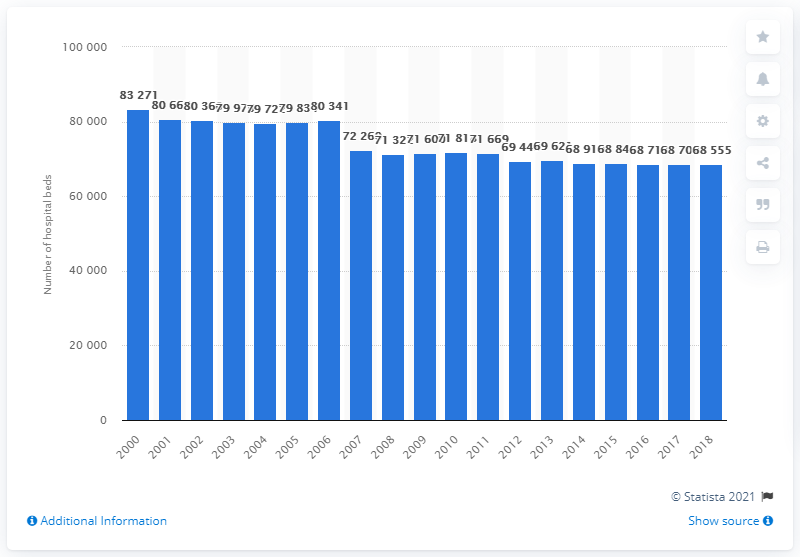Highlight a few significant elements in this photo. In 2000, the number of hospital beds in Hungary reached its peak. In 2000, the number of hospital beds in Hungary was 83,271. 